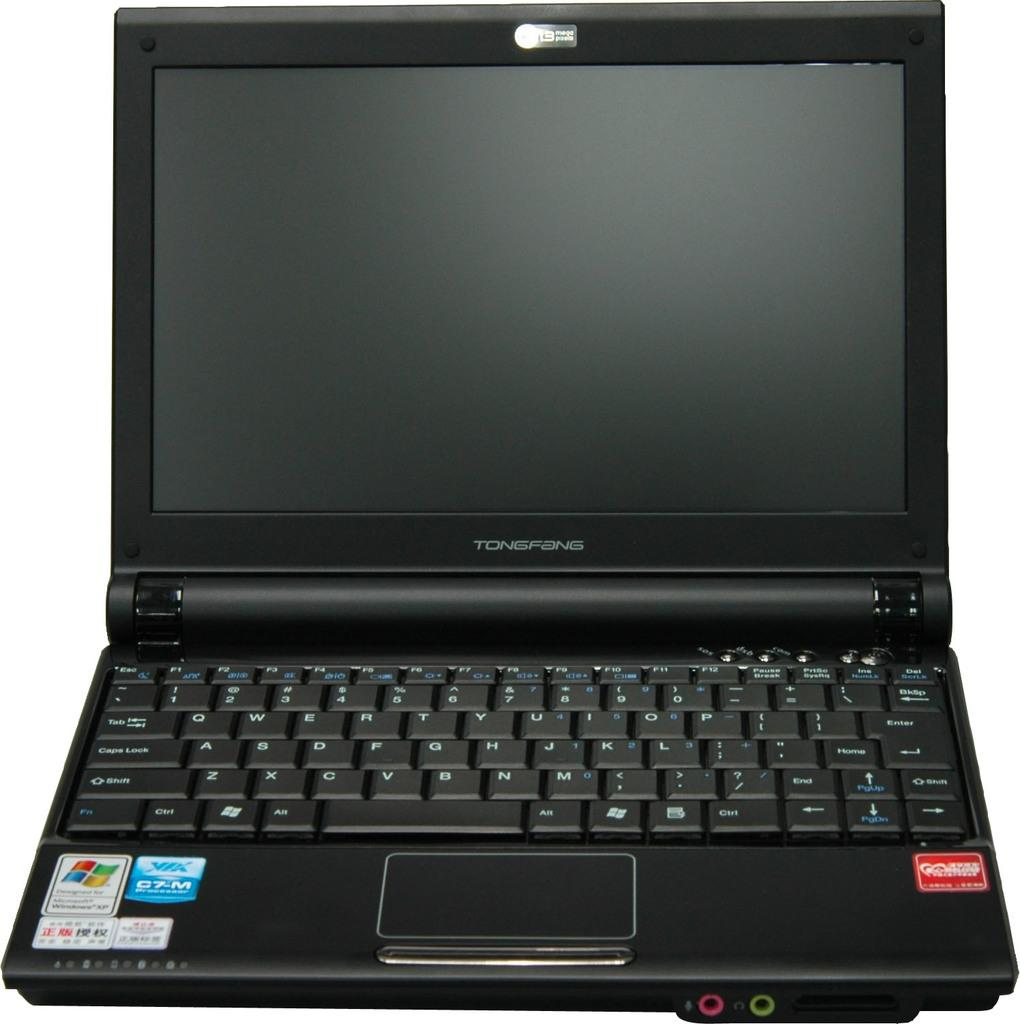<image>
Describe the image concisely. a Tongfang laptop that has a black screen on it 